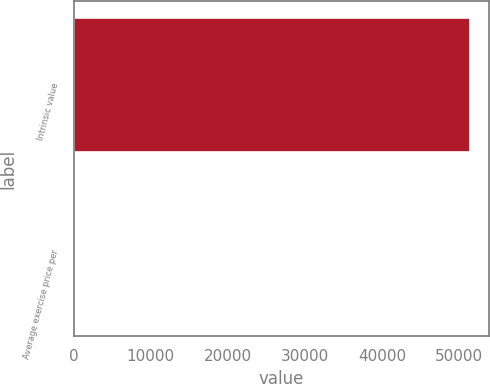Convert chart. <chart><loc_0><loc_0><loc_500><loc_500><bar_chart><fcel>Intrinsic value<fcel>Average exercise price per<nl><fcel>51408<fcel>30.06<nl></chart> 